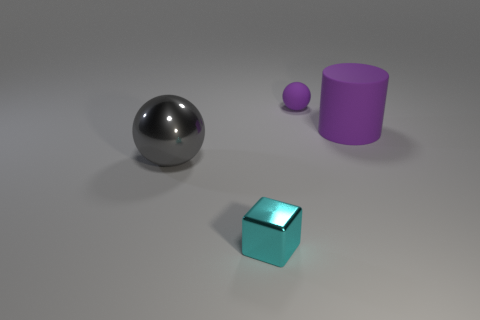What shape is the small object that is behind the metal ball? sphere 